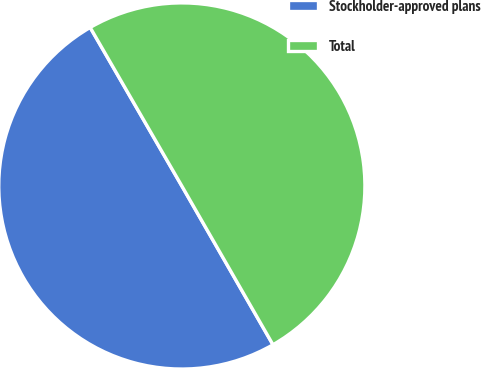<chart> <loc_0><loc_0><loc_500><loc_500><pie_chart><fcel>Stockholder-approved plans<fcel>Total<nl><fcel>49.95%<fcel>50.05%<nl></chart> 